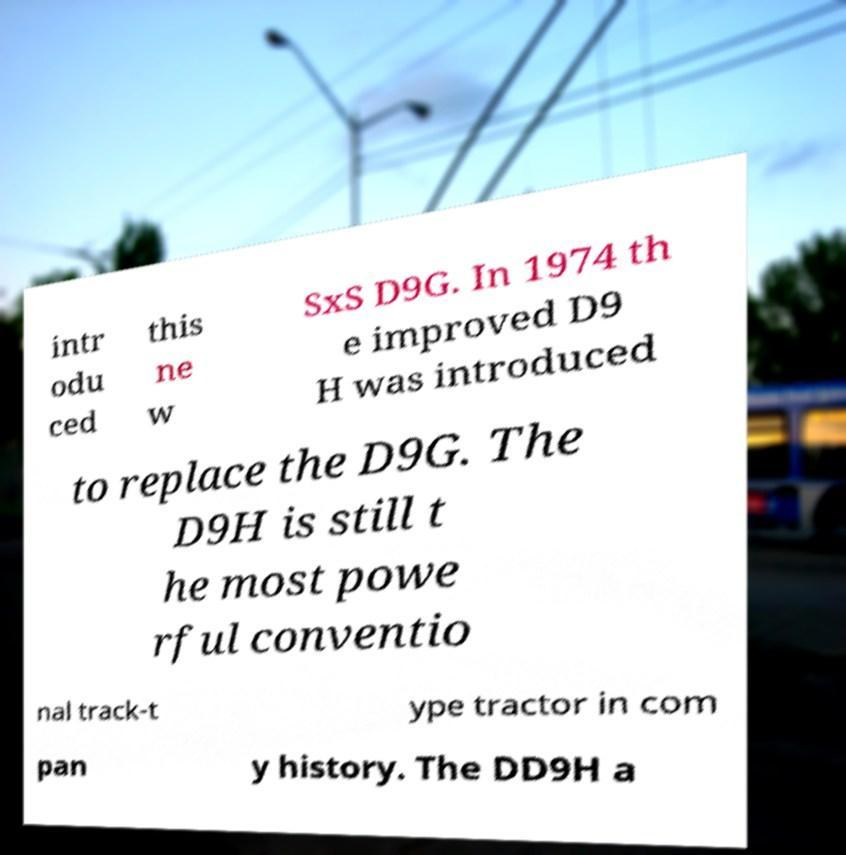Please identify and transcribe the text found in this image. intr odu ced this ne w SxS D9G. In 1974 th e improved D9 H was introduced to replace the D9G. The D9H is still t he most powe rful conventio nal track-t ype tractor in com pan y history. The DD9H a 